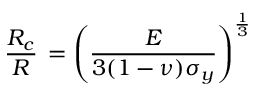<formula> <loc_0><loc_0><loc_500><loc_500>\frac { R _ { c } } { R } \, = \left ( \frac { E } { 3 ( 1 - \nu ) \sigma _ { y } } \right ) ^ { \frac { 1 } { 3 } }</formula> 